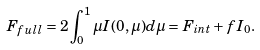Convert formula to latex. <formula><loc_0><loc_0><loc_500><loc_500>F _ { f u l l } = 2 \int _ { 0 } ^ { 1 } \mu I ( 0 , \mu ) d \mu = F _ { i n t } + f I _ { 0 } .</formula> 